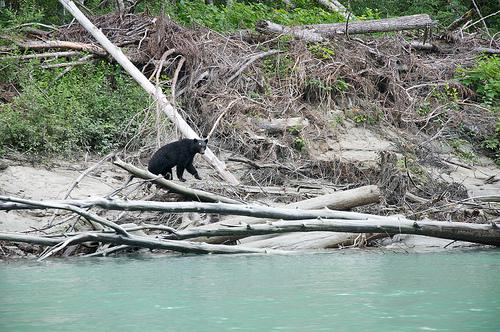Question: where was this picture taken?
Choices:
A. By a lake.
B. By a pond.
C. By the river.
D. By a peninsula.
Answer with the letter. Answer: C Question: what type of animal is pictured?
Choices:
A. A dog.
B. A cat.
C. A pig.
D. A bear.
Answer with the letter. Answer: D Question: how many zebras are in the picture?
Choices:
A. One.
B. Two.
C. Four.
D. Zero.
Answer with the letter. Answer: D Question: how many people are feeding the bear?
Choices:
A. One.
B. Two.
C. Zero.
D. Three.
Answer with the letter. Answer: C 